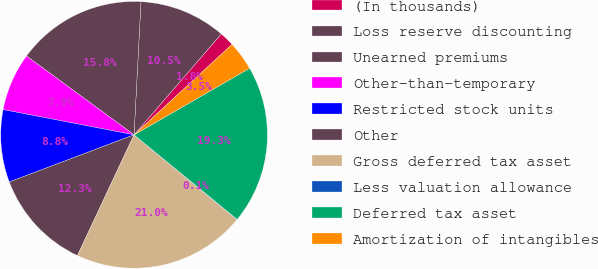<chart> <loc_0><loc_0><loc_500><loc_500><pie_chart><fcel>(In thousands)<fcel>Loss reserve discounting<fcel>Unearned premiums<fcel>Other-than-temporary<fcel>Restricted stock units<fcel>Other<fcel>Gross deferred tax asset<fcel>Less valuation allowance<fcel>Deferred tax asset<fcel>Amortization of intangibles<nl><fcel>1.79%<fcel>10.52%<fcel>15.76%<fcel>7.03%<fcel>8.78%<fcel>12.27%<fcel>21.0%<fcel>0.05%<fcel>19.25%<fcel>3.54%<nl></chart> 